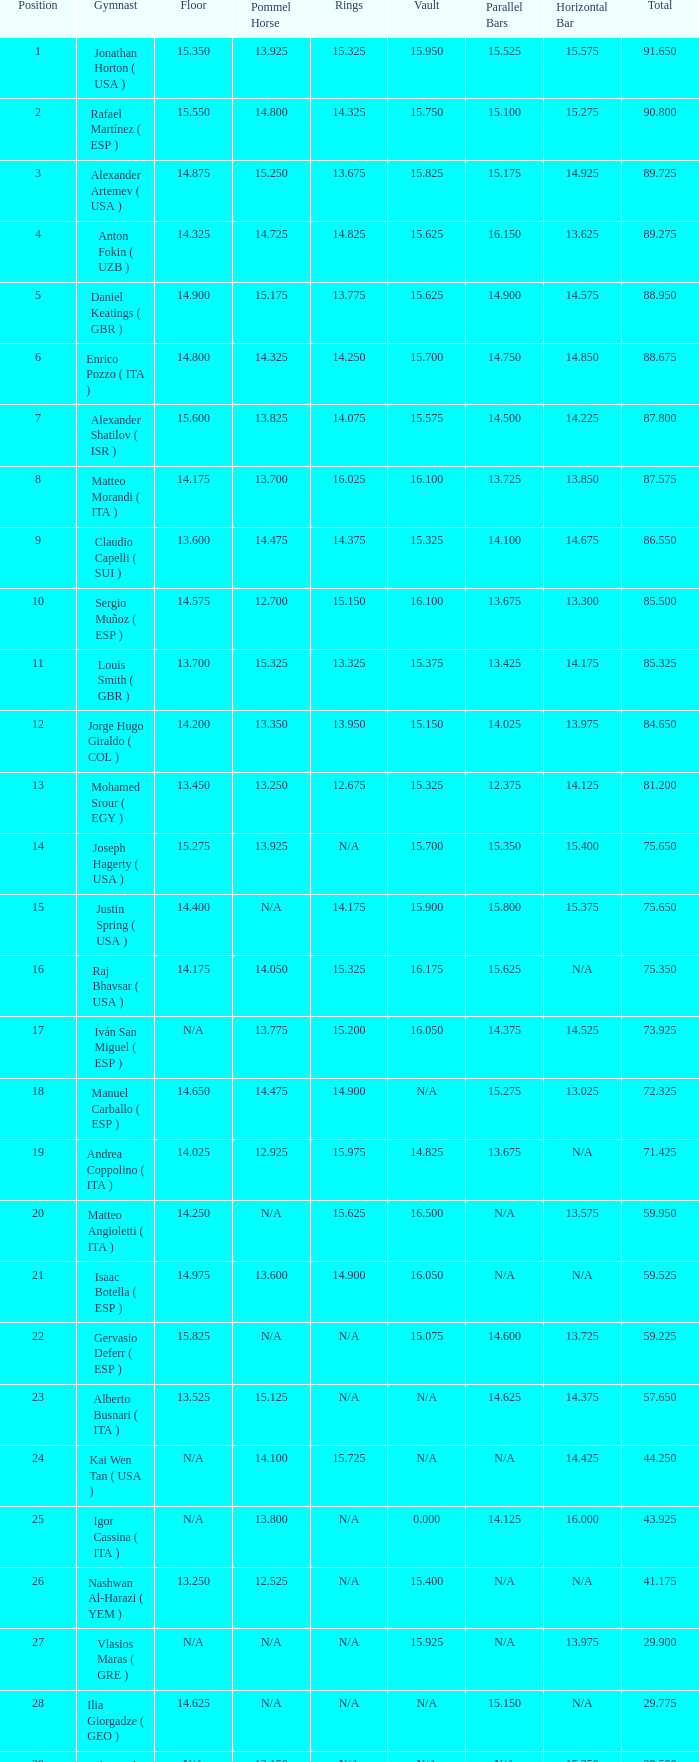How many gymnasts can be found if there are 14.025 parallel bars? 1.0. 